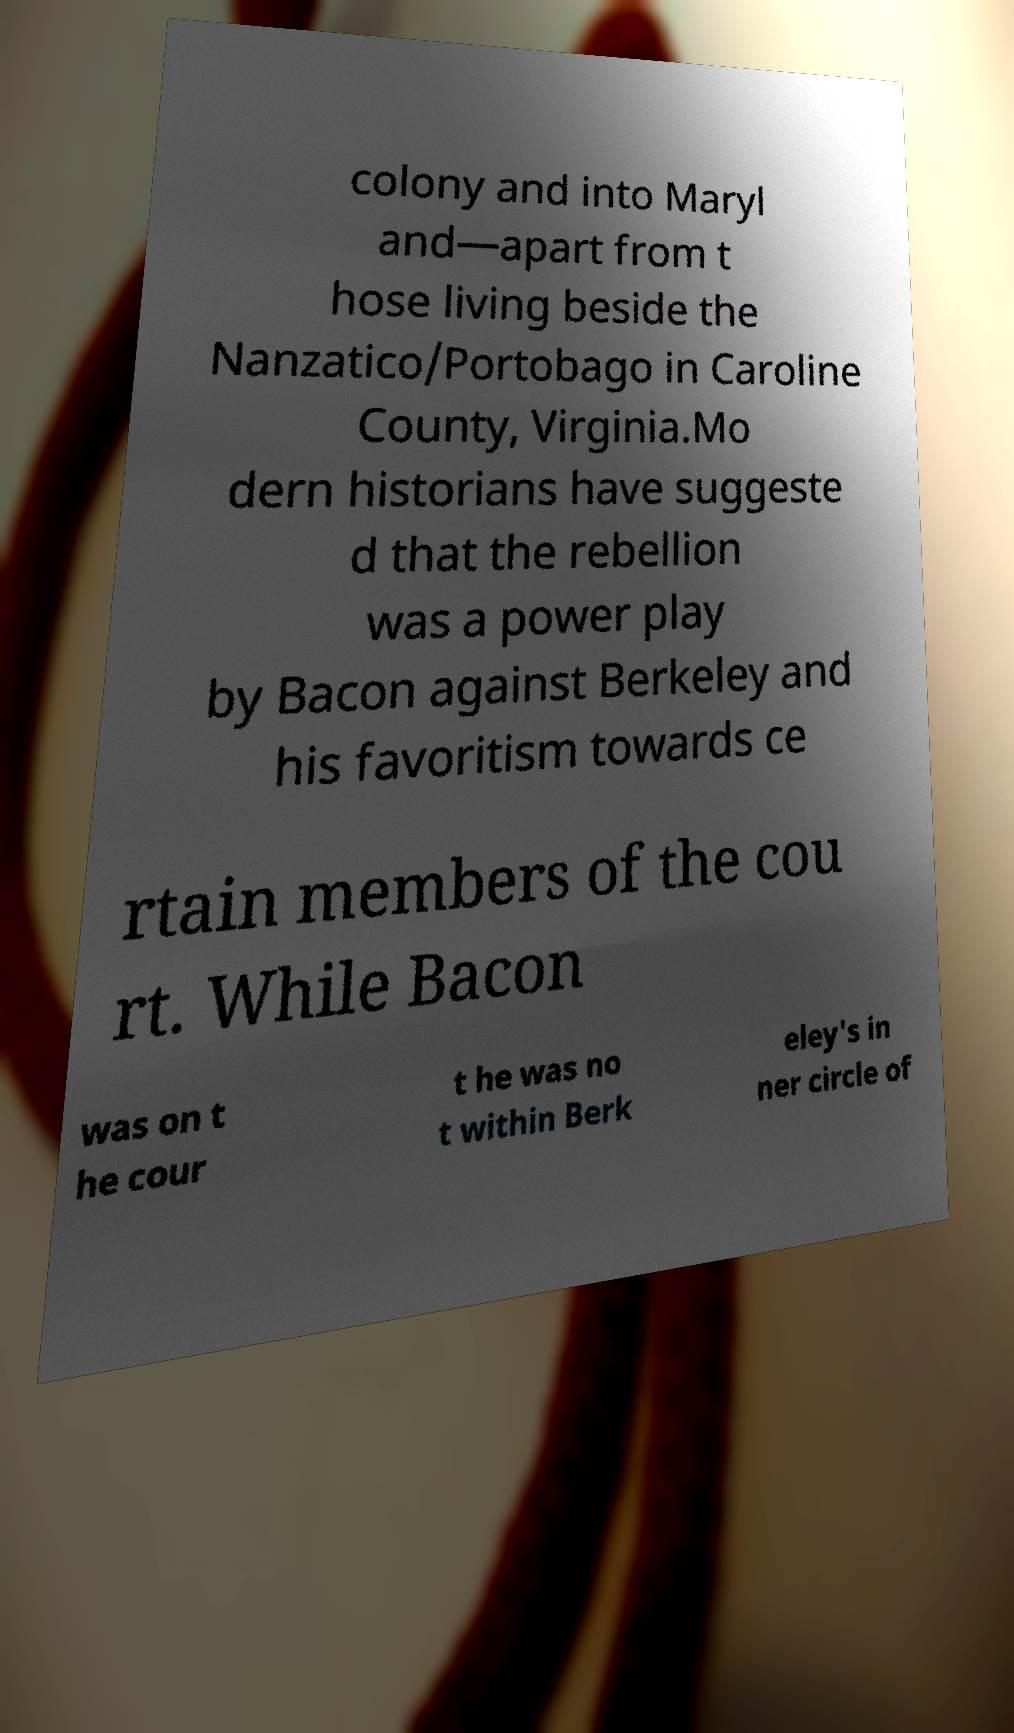Could you assist in decoding the text presented in this image and type it out clearly? colony and into Maryl and—apart from t hose living beside the Nanzatico/Portobago in Caroline County, Virginia.Mo dern historians have suggeste d that the rebellion was a power play by Bacon against Berkeley and his favoritism towards ce rtain members of the cou rt. While Bacon was on t he cour t he was no t within Berk eley's in ner circle of 